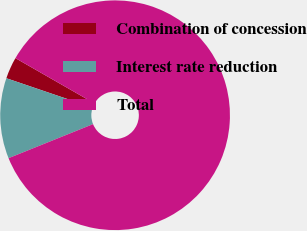Convert chart to OTSL. <chart><loc_0><loc_0><loc_500><loc_500><pie_chart><fcel>Combination of concession<fcel>Interest rate reduction<fcel>Total<nl><fcel>3.06%<fcel>11.32%<fcel>85.62%<nl></chart> 